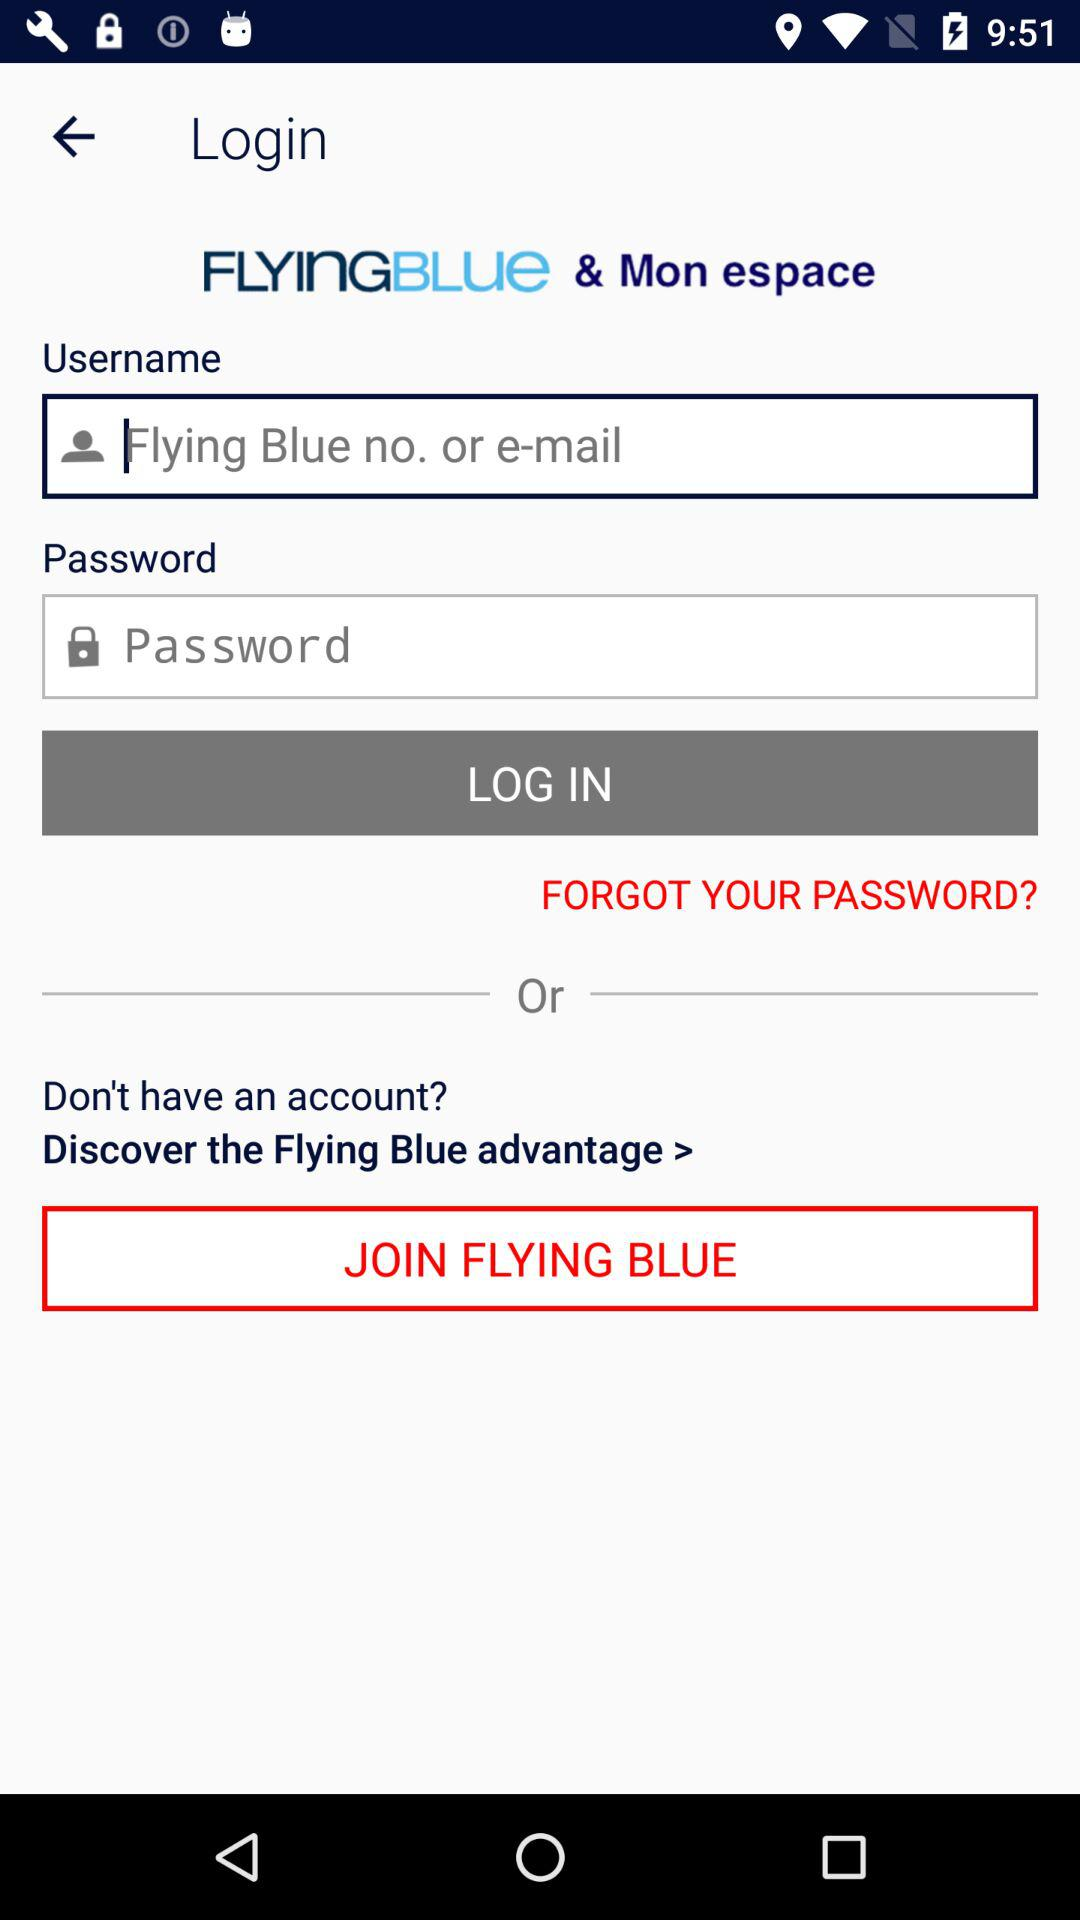How many text inputs are in the login form?
Answer the question using a single word or phrase. 2 